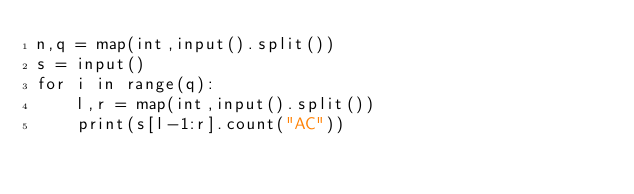Convert code to text. <code><loc_0><loc_0><loc_500><loc_500><_Python_>n,q = map(int,input().split())
s = input()
for i in range(q):
    l,r = map(int,input().split())
    print(s[l-1:r].count("AC"))</code> 